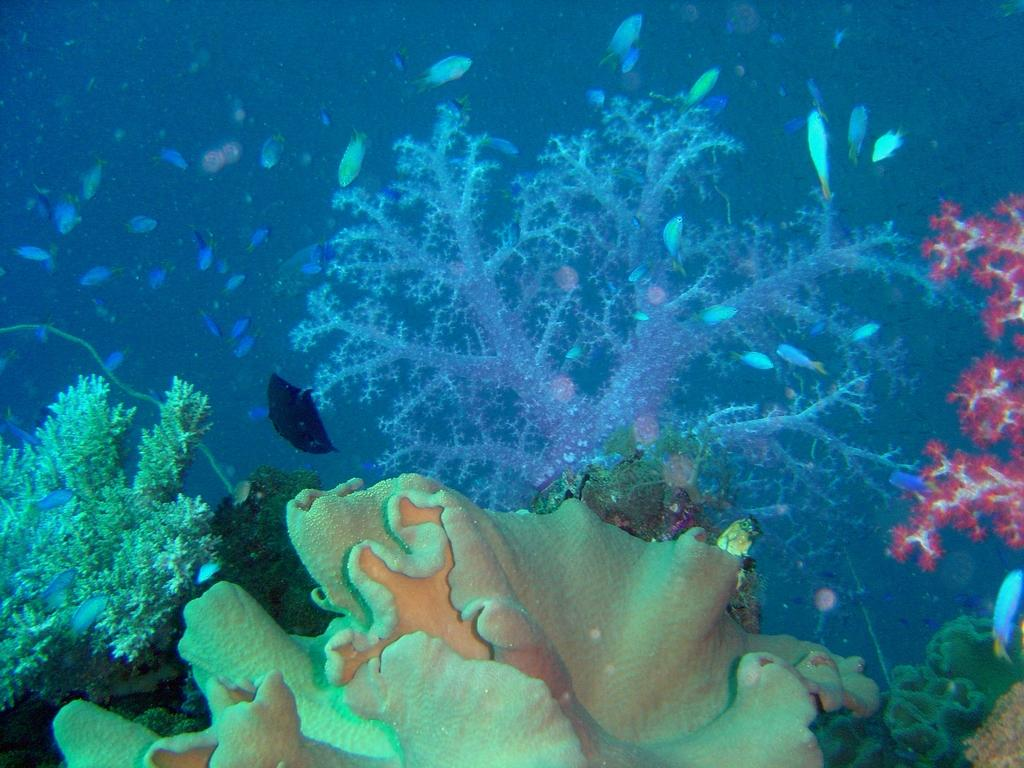What type of environment is shown in the image? The image depicts an underwater environment. What can be found in this underwater environment? There are coral plants and fishes in the image. How is the hose used in the underwater environment in the image? There is no hose present in the image; it is an underwater environment with coral plants and fishes. 